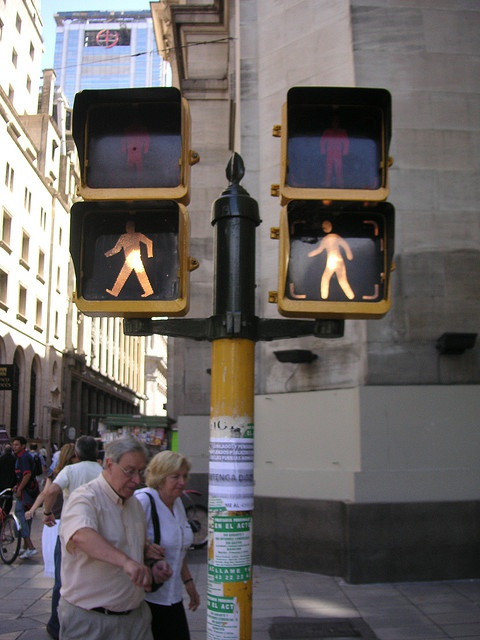Describe the objects in this image and their specific colors. I can see traffic light in white, black, gray, tan, and maroon tones, people in white, gray, darkgray, black, and maroon tones, traffic light in white, black, gray, tan, and olive tones, people in white, black, and gray tones, and people in white, black, darkgray, and gray tones in this image. 